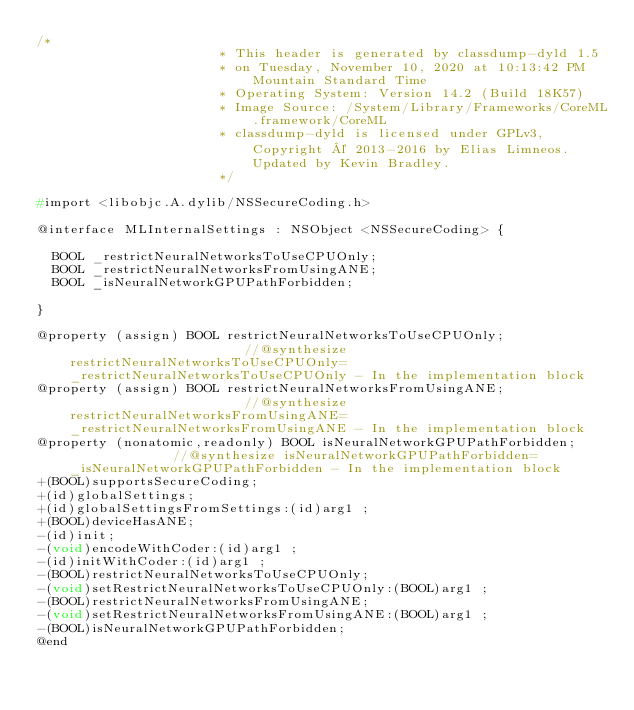Convert code to text. <code><loc_0><loc_0><loc_500><loc_500><_C_>/*
                       * This header is generated by classdump-dyld 1.5
                       * on Tuesday, November 10, 2020 at 10:13:42 PM Mountain Standard Time
                       * Operating System: Version 14.2 (Build 18K57)
                       * Image Source: /System/Library/Frameworks/CoreML.framework/CoreML
                       * classdump-dyld is licensed under GPLv3, Copyright © 2013-2016 by Elias Limneos. Updated by Kevin Bradley.
                       */

#import <libobjc.A.dylib/NSSecureCoding.h>

@interface MLInternalSettings : NSObject <NSSecureCoding> {

	BOOL _restrictNeuralNetworksToUseCPUOnly;
	BOOL _restrictNeuralNetworksFromUsingANE;
	BOOL _isNeuralNetworkGPUPathForbidden;

}

@property (assign) BOOL restrictNeuralNetworksToUseCPUOnly;                       //@synthesize restrictNeuralNetworksToUseCPUOnly=_restrictNeuralNetworksToUseCPUOnly - In the implementation block
@property (assign) BOOL restrictNeuralNetworksFromUsingANE;                       //@synthesize restrictNeuralNetworksFromUsingANE=_restrictNeuralNetworksFromUsingANE - In the implementation block
@property (nonatomic,readonly) BOOL isNeuralNetworkGPUPathForbidden;              //@synthesize isNeuralNetworkGPUPathForbidden=_isNeuralNetworkGPUPathForbidden - In the implementation block
+(BOOL)supportsSecureCoding;
+(id)globalSettings;
+(id)globalSettingsFromSettings:(id)arg1 ;
+(BOOL)deviceHasANE;
-(id)init;
-(void)encodeWithCoder:(id)arg1 ;
-(id)initWithCoder:(id)arg1 ;
-(BOOL)restrictNeuralNetworksToUseCPUOnly;
-(void)setRestrictNeuralNetworksToUseCPUOnly:(BOOL)arg1 ;
-(BOOL)restrictNeuralNetworksFromUsingANE;
-(void)setRestrictNeuralNetworksFromUsingANE:(BOOL)arg1 ;
-(BOOL)isNeuralNetworkGPUPathForbidden;
@end

</code> 